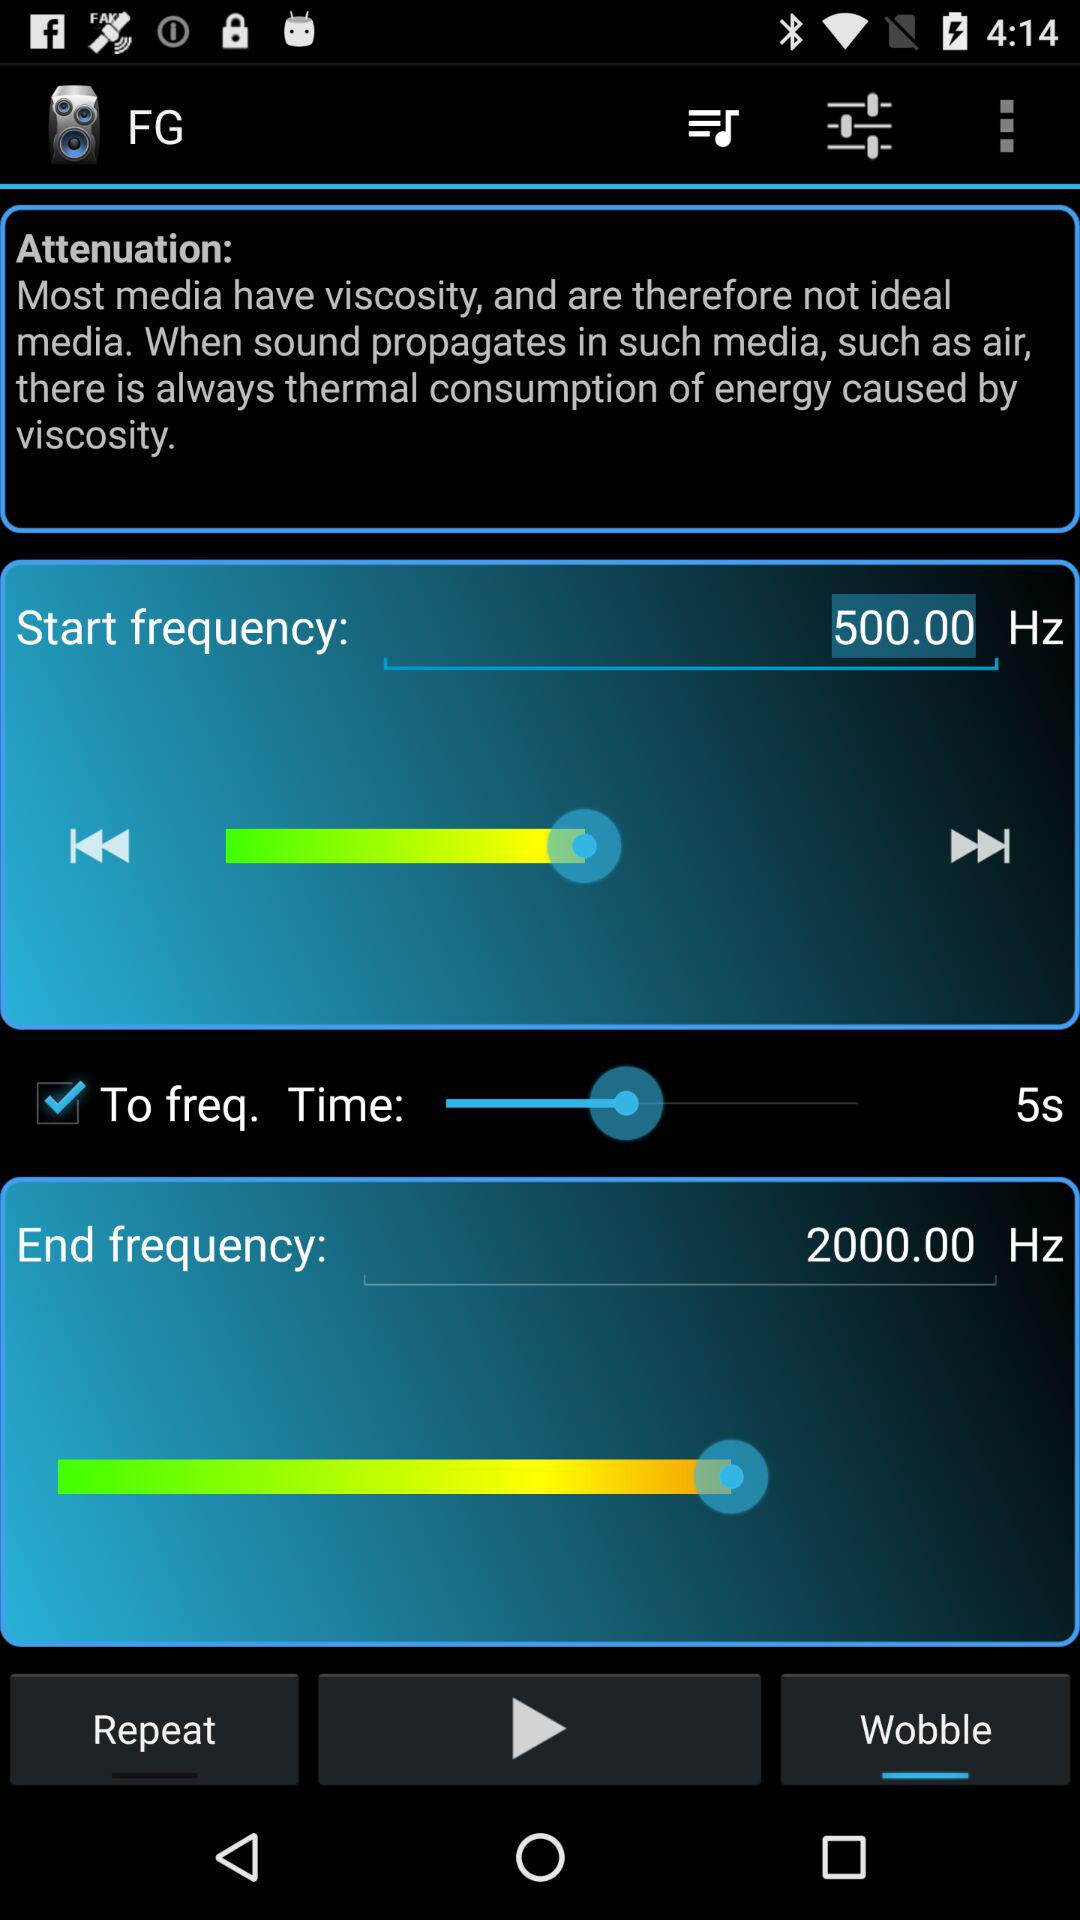What is the start frequency? The start frequency is 500 Hz. 